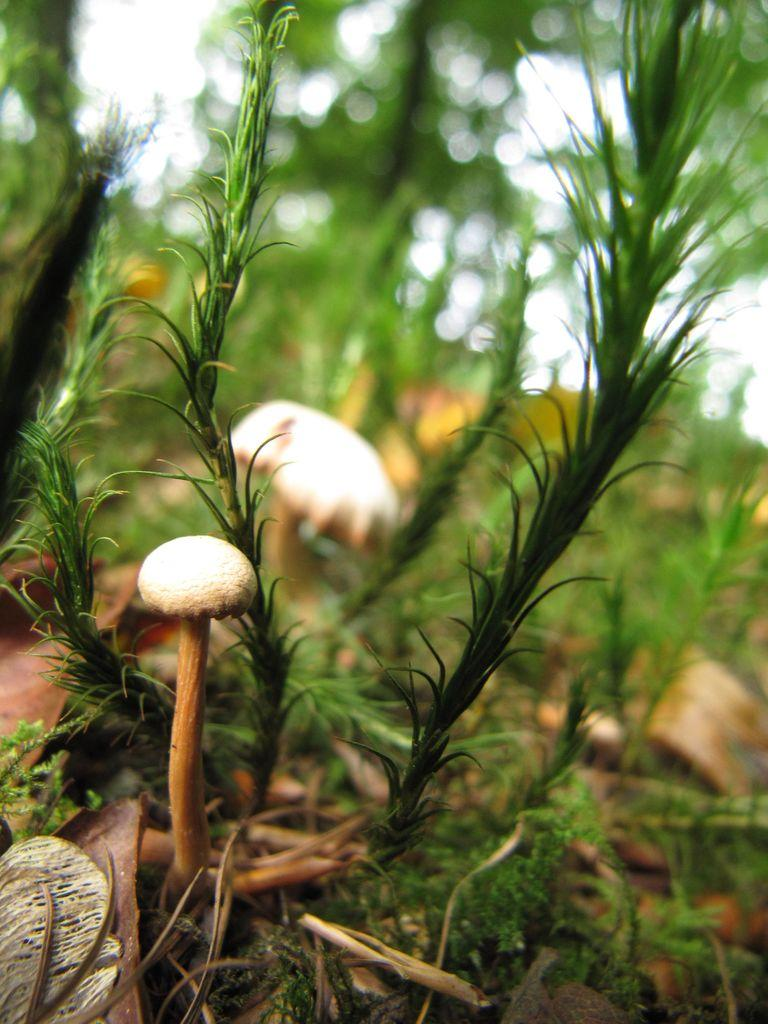What type of living organisms can be seen in the image? Plants can be seen in the image. What color are the plants in the image? The plants are green in color. What other objects can be seen in the image besides the plants? There are two mushrooms in the image. What color are the mushrooms in the image? The mushrooms are white in color. How would you describe the background of the image? The top of the image has a blurred background. What type of drum can be seen in the image? There is no drum present in the image; it features plants and mushrooms. Are there any police officers visible in the image? There are no police officers present in the image. 